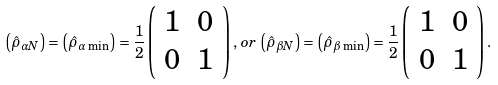<formula> <loc_0><loc_0><loc_500><loc_500>\left ( \hat { \rho } _ { \alpha N } \right ) = \left ( \hat { \rho } _ { \alpha \, \min } \right ) = \frac { 1 } { 2 } \left ( \begin{array} { c c } 1 & 0 \\ 0 & 1 \end{array} \right ) , \, o r \, \left ( \hat { \rho } _ { \beta N } \right ) = \left ( \hat { \rho } _ { \beta \, \min } \right ) = \frac { 1 } { 2 } \left ( \begin{array} { c c } 1 & 0 \\ 0 & 1 \end{array} \right ) .</formula> 